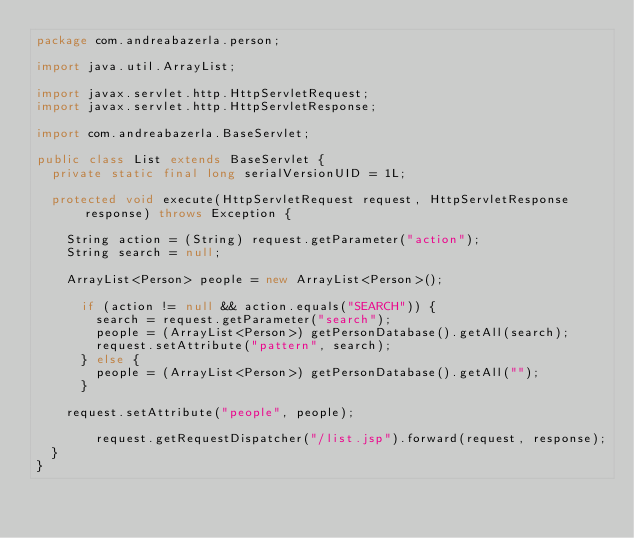<code> <loc_0><loc_0><loc_500><loc_500><_Java_>package com.andreabazerla.person;

import java.util.ArrayList;

import javax.servlet.http.HttpServletRequest;
import javax.servlet.http.HttpServletResponse;

import com.andreabazerla.BaseServlet;

public class List extends BaseServlet {
	private static final long serialVersionUID = 1L;

	protected void execute(HttpServletRequest request, HttpServletResponse response) throws Exception {
	    		
		String action = (String) request.getParameter("action");
		String search = null;
		
		ArrayList<Person> people = new ArrayList<Person>();			

			if (action != null && action.equals("SEARCH")) {
				search = request.getParameter("search");
				people = (ArrayList<Person>) getPersonDatabase().getAll(search);
				request.setAttribute("pattern", search);
			} else {
				people = (ArrayList<Person>) getPersonDatabase().getAll("");
			}
		
		request.setAttribute("people", people);
		
        request.getRequestDispatcher("/list.jsp").forward(request, response);
	}
}
</code> 